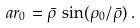Convert formula to latex. <formula><loc_0><loc_0><loc_500><loc_500>a r _ { 0 } = \bar { \rho } \, \sin ( \rho _ { 0 } / \bar { \rho } ) \, .</formula> 